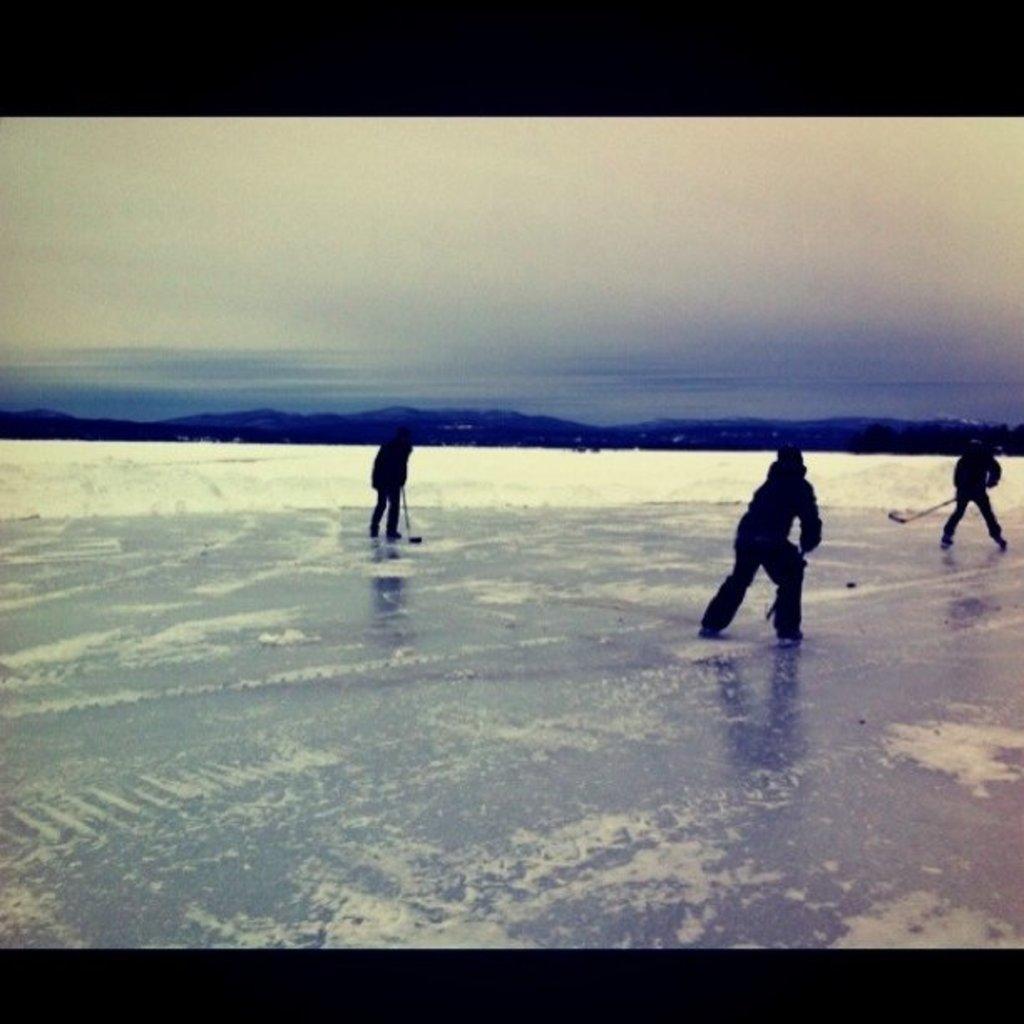Describe this image in one or two sentences. In this image we can see three persons playing ice hockey. Behind the persons we can see snow and mountains. At the top we can see the sky. 